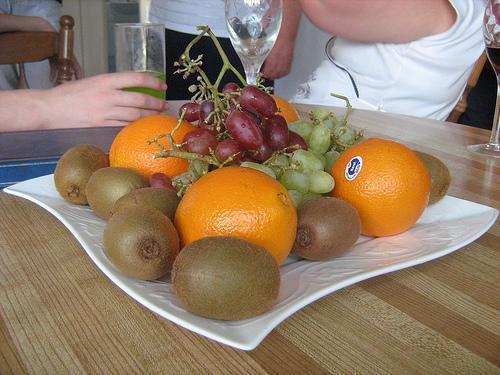How many people are there?
Give a very brief answer. 2. 